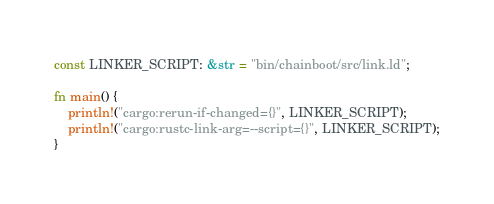Convert code to text. <code><loc_0><loc_0><loc_500><loc_500><_Rust_>const LINKER_SCRIPT: &str = "bin/chainboot/src/link.ld";

fn main() {
    println!("cargo:rerun-if-changed={}", LINKER_SCRIPT);
    println!("cargo:rustc-link-arg=--script={}", LINKER_SCRIPT);
}
</code> 